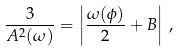Convert formula to latex. <formula><loc_0><loc_0><loc_500><loc_500>\frac { 3 } { A ^ { 2 } ( \omega ) } = \left | \frac { \omega ( \phi ) } { 2 } + B \right | \, ,</formula> 